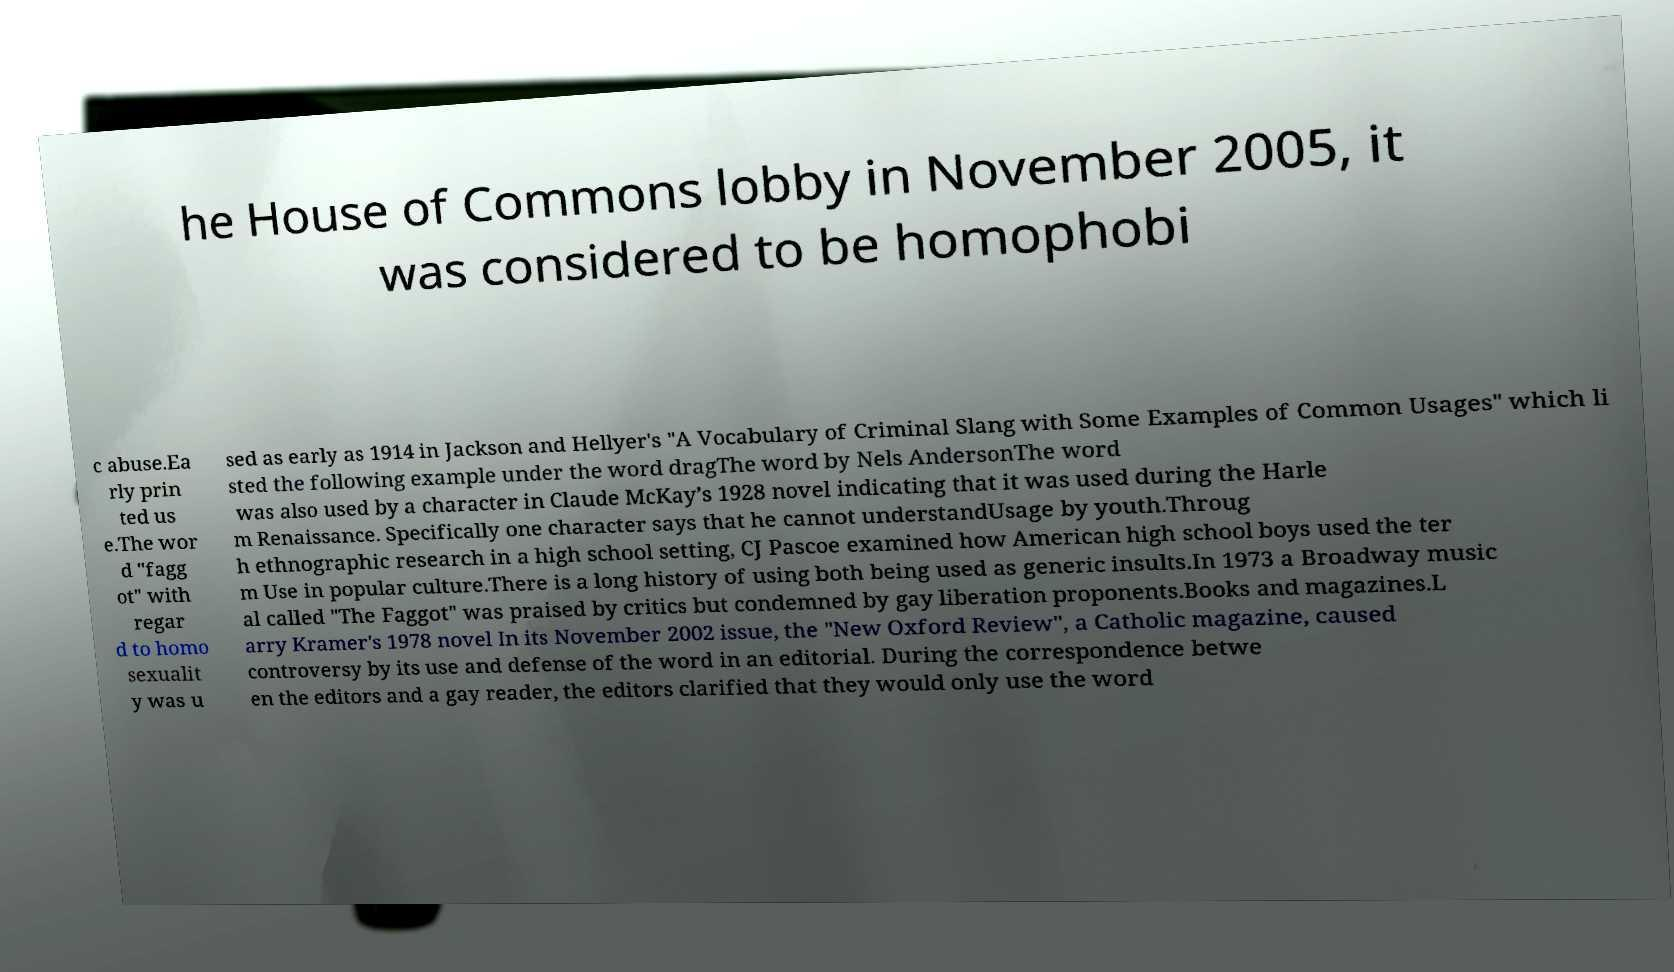Could you extract and type out the text from this image? he House of Commons lobby in November 2005, it was considered to be homophobi c abuse.Ea rly prin ted us e.The wor d "fagg ot" with regar d to homo sexualit y was u sed as early as 1914 in Jackson and Hellyer's "A Vocabulary of Criminal Slang with Some Examples of Common Usages" which li sted the following example under the word dragThe word by Nels AndersonThe word was also used by a character in Claude McKay’s 1928 novel indicating that it was used during the Harle m Renaissance. Specifically one character says that he cannot understandUsage by youth.Throug h ethnographic research in a high school setting, CJ Pascoe examined how American high school boys used the ter m Use in popular culture.There is a long history of using both being used as generic insults.In 1973 a Broadway music al called "The Faggot" was praised by critics but condemned by gay liberation proponents.Books and magazines.L arry Kramer's 1978 novel In its November 2002 issue, the "New Oxford Review", a Catholic magazine, caused controversy by its use and defense of the word in an editorial. During the correspondence betwe en the editors and a gay reader, the editors clarified that they would only use the word 